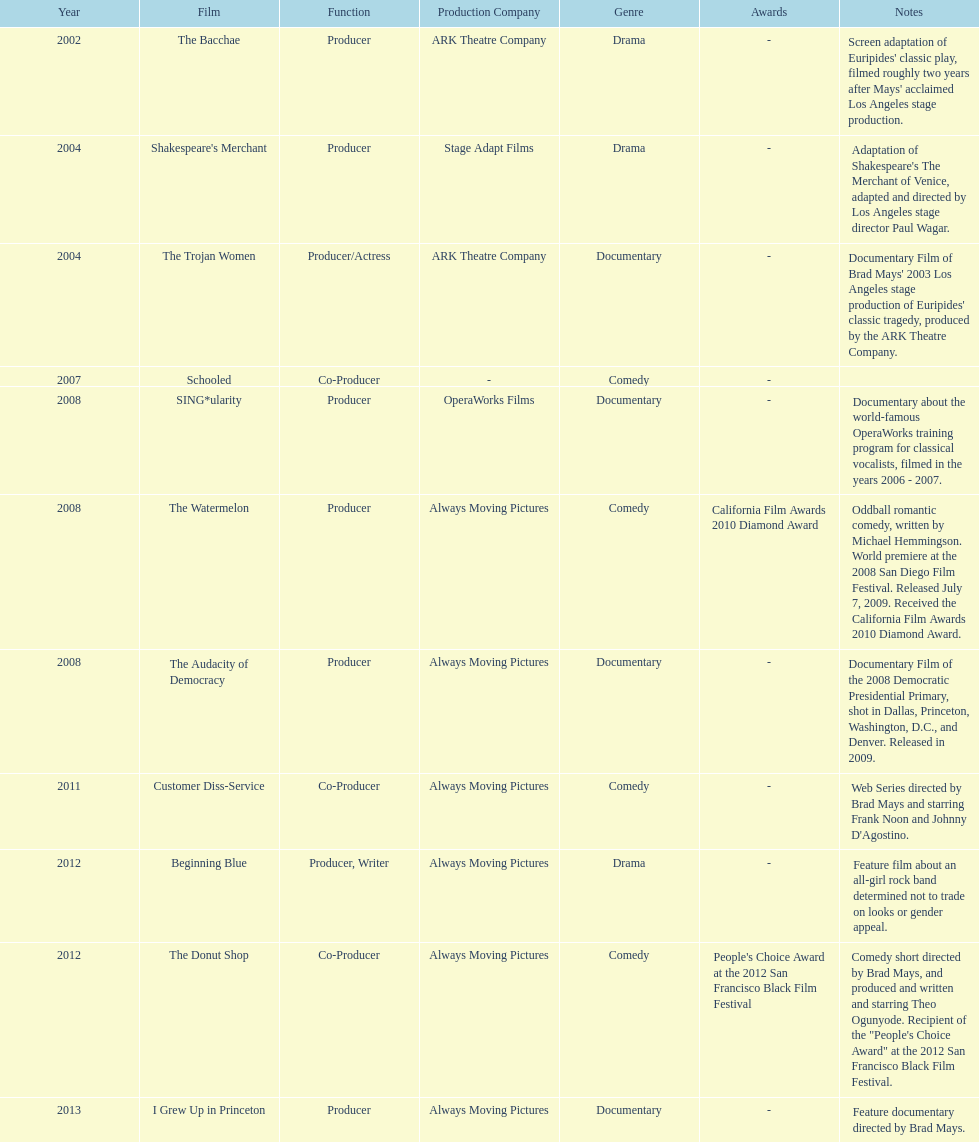Who was the first producer that made the film sing*ularity? Lorenda Starfelt. 